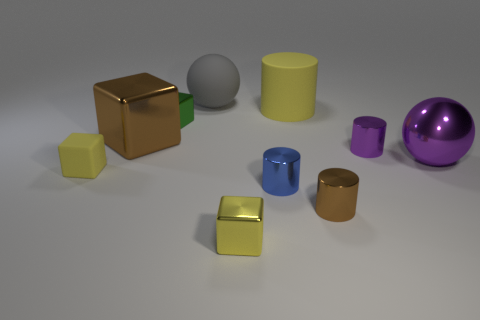Subtract all gray spheres. How many yellow blocks are left? 2 Subtract all small metallic cylinders. How many cylinders are left? 1 Subtract all blue cylinders. How many cylinders are left? 3 Subtract 1 blocks. How many blocks are left? 3 Subtract all green cylinders. Subtract all cyan blocks. How many cylinders are left? 4 Subtract all cylinders. How many objects are left? 6 Add 1 green metallic blocks. How many green metallic blocks exist? 2 Subtract 1 blue cylinders. How many objects are left? 9 Subtract all small purple cylinders. Subtract all tiny brown metallic things. How many objects are left? 8 Add 8 large brown blocks. How many large brown blocks are left? 9 